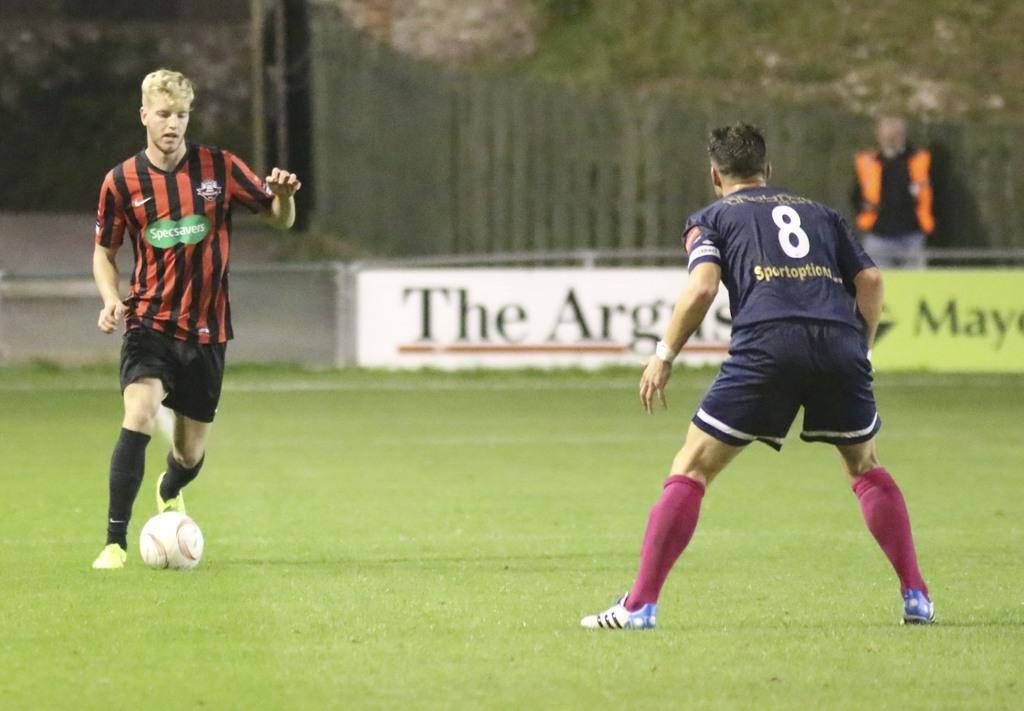How would you summarize this image in a sentence or two? In this picture there are two men playing a game and we can see ball on the grass. In the background of the image there is a man standing and we can see hoardings and fence. 